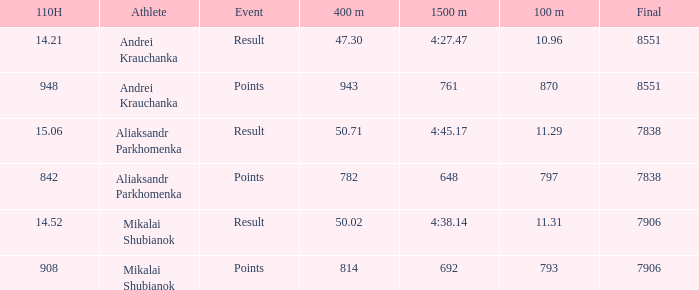What was the final for Mikalai Shubianok who had a 110H less than 908? 7906.0. Write the full table. {'header': ['110H', 'Athlete', 'Event', '400 m', '1500 m', '100 m', 'Final'], 'rows': [['14.21', 'Andrei Krauchanka', 'Result', '47.30', '4:27.47', '10.96', '8551'], ['948', 'Andrei Krauchanka', 'Points', '943', '761', '870', '8551'], ['15.06', 'Aliaksandr Parkhomenka', 'Result', '50.71', '4:45.17', '11.29', '7838'], ['842', 'Aliaksandr Parkhomenka', 'Points', '782', '648', '797', '7838'], ['14.52', 'Mikalai Shubianok', 'Result', '50.02', '4:38.14', '11.31', '7906'], ['908', 'Mikalai Shubianok', 'Points', '814', '692', '793', '7906']]} 